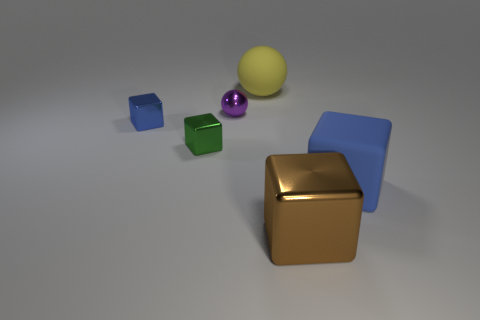Add 1 red rubber things. How many objects exist? 7 Subtract all balls. How many objects are left? 4 Add 4 large brown objects. How many large brown objects are left? 5 Add 5 tiny yellow cylinders. How many tiny yellow cylinders exist? 5 Subtract 0 red cylinders. How many objects are left? 6 Subtract all green metal cubes. Subtract all tiny purple metal spheres. How many objects are left? 4 